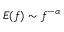Convert formula to latex. <formula><loc_0><loc_0><loc_500><loc_500>E ( f ) \sim f ^ { - \alpha }</formula> 